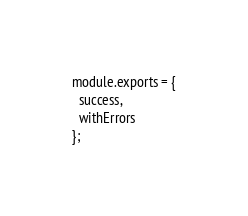<code> <loc_0><loc_0><loc_500><loc_500><_JavaScript_>
module.exports = {
  success,
  withErrors
};
</code> 